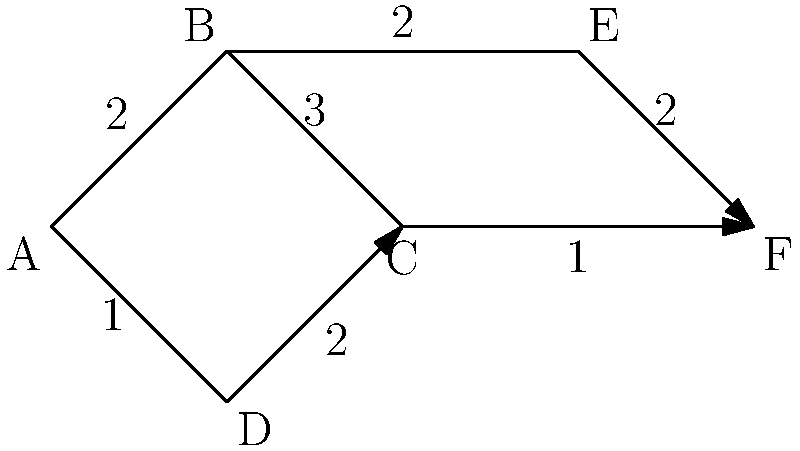In this network representing a simplified routing map, packets need to be sent from node A to node F. If the routing algorithm always chooses the path with the lowest total weight (where weight represents transmission time in milliseconds), which path will the packets take? Express your answer as a sequence of nodes. Let's approach this step-by-step, considering all possible paths from A to F:

1. Path A-B-C-F:
   Weight = 2 + 3 + 1 = 6 ms

2. Path A-B-E-F:
   Weight = 2 + 2 + 2 = 6 ms

3. Path A-D-C-F:
   Weight = 1 + 2 + 1 = 4 ms

The routing algorithm will choose the path with the lowest total weight. In this case, the path A-D-C-F has the lowest total weight of 4 ms.

This choice aligns with the concept of optimal routing in computer networks, where the goal is to minimize delay and maximize efficiency. The algorithm considers the cumulative weight (or cost) of each possible path and selects the one that offers the least total weight, ensuring the fastest delivery of packets from source to destination.
Answer: A-D-C-F 